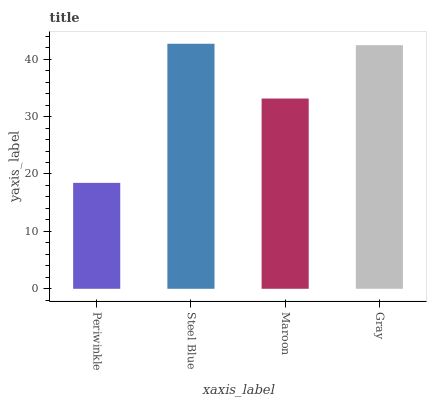Is Periwinkle the minimum?
Answer yes or no. Yes. Is Steel Blue the maximum?
Answer yes or no. Yes. Is Maroon the minimum?
Answer yes or no. No. Is Maroon the maximum?
Answer yes or no. No. Is Steel Blue greater than Maroon?
Answer yes or no. Yes. Is Maroon less than Steel Blue?
Answer yes or no. Yes. Is Maroon greater than Steel Blue?
Answer yes or no. No. Is Steel Blue less than Maroon?
Answer yes or no. No. Is Gray the high median?
Answer yes or no. Yes. Is Maroon the low median?
Answer yes or no. Yes. Is Maroon the high median?
Answer yes or no. No. Is Gray the low median?
Answer yes or no. No. 